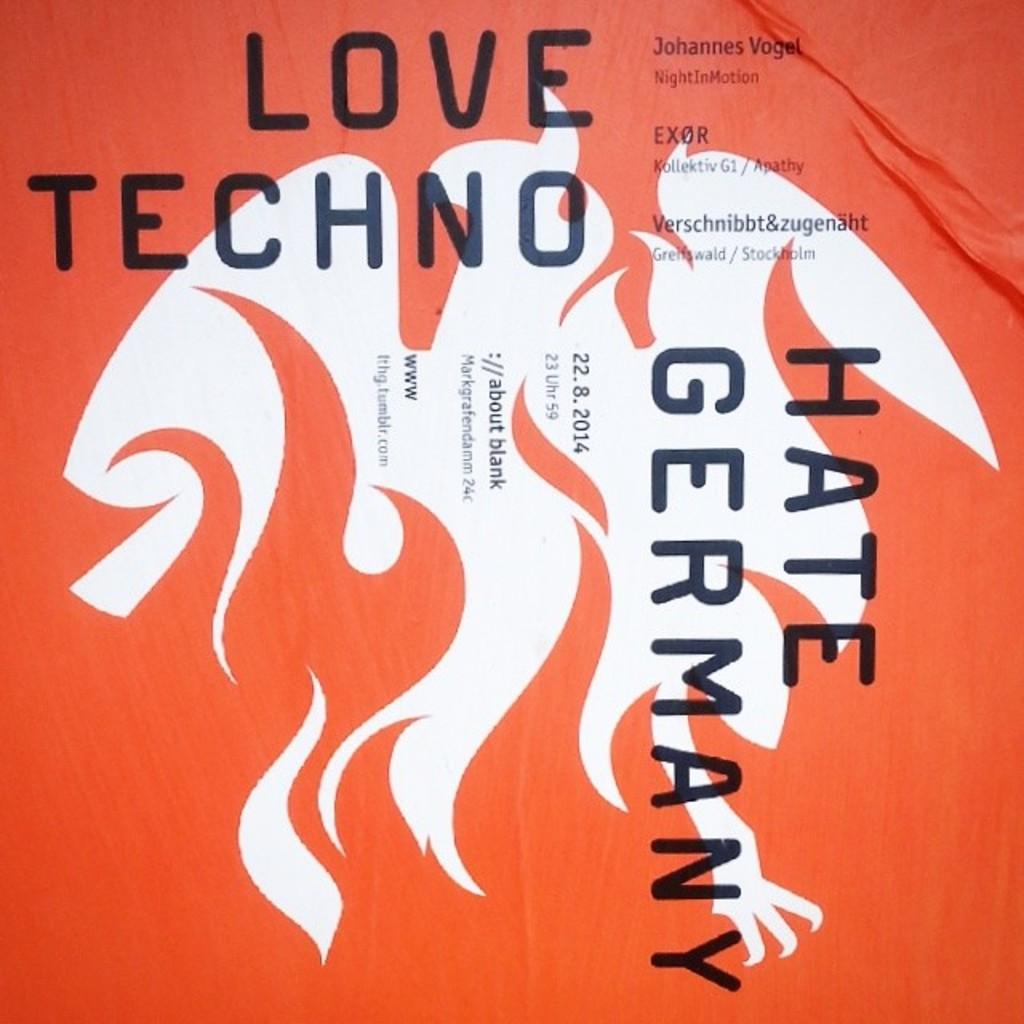<image>
Create a compact narrative representing the image presented. The poster wants you to hate the country Germany. 